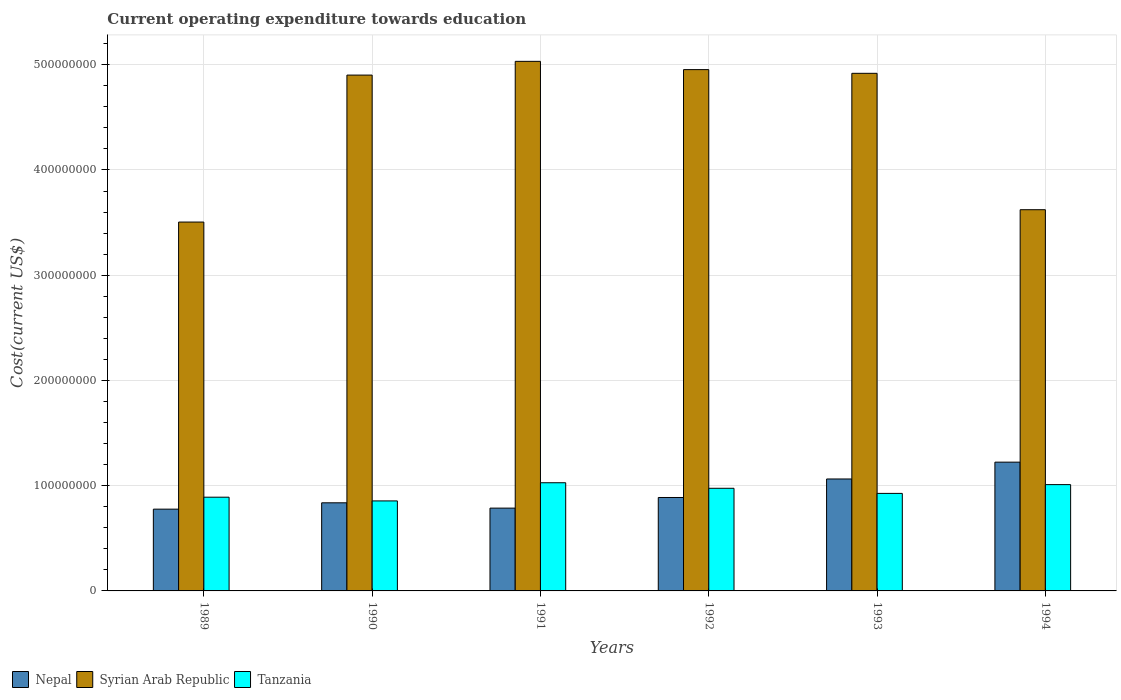How many different coloured bars are there?
Your answer should be very brief. 3. How many groups of bars are there?
Give a very brief answer. 6. Are the number of bars on each tick of the X-axis equal?
Offer a terse response. Yes. How many bars are there on the 3rd tick from the left?
Give a very brief answer. 3. What is the expenditure towards education in Tanzania in 1994?
Your response must be concise. 1.01e+08. Across all years, what is the maximum expenditure towards education in Tanzania?
Make the answer very short. 1.03e+08. Across all years, what is the minimum expenditure towards education in Syrian Arab Republic?
Offer a very short reply. 3.50e+08. In which year was the expenditure towards education in Syrian Arab Republic minimum?
Provide a succinct answer. 1989. What is the total expenditure towards education in Nepal in the graph?
Offer a very short reply. 5.58e+08. What is the difference between the expenditure towards education in Syrian Arab Republic in 1992 and that in 1993?
Your answer should be very brief. 3.51e+06. What is the difference between the expenditure towards education in Syrian Arab Republic in 1991 and the expenditure towards education in Nepal in 1990?
Give a very brief answer. 4.19e+08. What is the average expenditure towards education in Tanzania per year?
Your answer should be very brief. 9.48e+07. In the year 1993, what is the difference between the expenditure towards education in Syrian Arab Republic and expenditure towards education in Tanzania?
Give a very brief answer. 3.99e+08. In how many years, is the expenditure towards education in Tanzania greater than 320000000 US$?
Keep it short and to the point. 0. What is the ratio of the expenditure towards education in Tanzania in 1989 to that in 1990?
Ensure brevity in your answer.  1.04. Is the expenditure towards education in Tanzania in 1991 less than that in 1994?
Offer a terse response. No. Is the difference between the expenditure towards education in Syrian Arab Republic in 1990 and 1991 greater than the difference between the expenditure towards education in Tanzania in 1990 and 1991?
Give a very brief answer. Yes. What is the difference between the highest and the second highest expenditure towards education in Tanzania?
Your answer should be very brief. 1.79e+06. What is the difference between the highest and the lowest expenditure towards education in Nepal?
Offer a terse response. 4.47e+07. In how many years, is the expenditure towards education in Syrian Arab Republic greater than the average expenditure towards education in Syrian Arab Republic taken over all years?
Provide a short and direct response. 4. Is the sum of the expenditure towards education in Nepal in 1990 and 1991 greater than the maximum expenditure towards education in Syrian Arab Republic across all years?
Provide a short and direct response. No. What does the 1st bar from the left in 1994 represents?
Provide a succinct answer. Nepal. What does the 2nd bar from the right in 1992 represents?
Offer a terse response. Syrian Arab Republic. Are all the bars in the graph horizontal?
Your answer should be very brief. No. How many years are there in the graph?
Your answer should be very brief. 6. What is the difference between two consecutive major ticks on the Y-axis?
Keep it short and to the point. 1.00e+08. What is the title of the graph?
Your answer should be very brief. Current operating expenditure towards education. What is the label or title of the Y-axis?
Offer a terse response. Cost(current US$). What is the Cost(current US$) of Nepal in 1989?
Provide a short and direct response. 7.77e+07. What is the Cost(current US$) in Syrian Arab Republic in 1989?
Offer a terse response. 3.50e+08. What is the Cost(current US$) in Tanzania in 1989?
Your answer should be compact. 8.91e+07. What is the Cost(current US$) in Nepal in 1990?
Offer a very short reply. 8.37e+07. What is the Cost(current US$) of Syrian Arab Republic in 1990?
Ensure brevity in your answer.  4.90e+08. What is the Cost(current US$) of Tanzania in 1990?
Your answer should be compact. 8.55e+07. What is the Cost(current US$) of Nepal in 1991?
Keep it short and to the point. 7.87e+07. What is the Cost(current US$) of Syrian Arab Republic in 1991?
Provide a short and direct response. 5.03e+08. What is the Cost(current US$) in Tanzania in 1991?
Your answer should be compact. 1.03e+08. What is the Cost(current US$) in Nepal in 1992?
Give a very brief answer. 8.88e+07. What is the Cost(current US$) in Syrian Arab Republic in 1992?
Give a very brief answer. 4.95e+08. What is the Cost(current US$) of Tanzania in 1992?
Ensure brevity in your answer.  9.75e+07. What is the Cost(current US$) of Nepal in 1993?
Keep it short and to the point. 1.06e+08. What is the Cost(current US$) of Syrian Arab Republic in 1993?
Provide a short and direct response. 4.92e+08. What is the Cost(current US$) of Tanzania in 1993?
Give a very brief answer. 9.27e+07. What is the Cost(current US$) in Nepal in 1994?
Your response must be concise. 1.22e+08. What is the Cost(current US$) of Syrian Arab Republic in 1994?
Offer a terse response. 3.62e+08. What is the Cost(current US$) in Tanzania in 1994?
Offer a terse response. 1.01e+08. Across all years, what is the maximum Cost(current US$) of Nepal?
Give a very brief answer. 1.22e+08. Across all years, what is the maximum Cost(current US$) of Syrian Arab Republic?
Offer a terse response. 5.03e+08. Across all years, what is the maximum Cost(current US$) of Tanzania?
Provide a succinct answer. 1.03e+08. Across all years, what is the minimum Cost(current US$) in Nepal?
Offer a very short reply. 7.77e+07. Across all years, what is the minimum Cost(current US$) of Syrian Arab Republic?
Give a very brief answer. 3.50e+08. Across all years, what is the minimum Cost(current US$) in Tanzania?
Ensure brevity in your answer.  8.55e+07. What is the total Cost(current US$) in Nepal in the graph?
Your response must be concise. 5.58e+08. What is the total Cost(current US$) in Syrian Arab Republic in the graph?
Offer a terse response. 2.69e+09. What is the total Cost(current US$) in Tanzania in the graph?
Ensure brevity in your answer.  5.69e+08. What is the difference between the Cost(current US$) in Nepal in 1989 and that in 1990?
Offer a terse response. -6.02e+06. What is the difference between the Cost(current US$) of Syrian Arab Republic in 1989 and that in 1990?
Keep it short and to the point. -1.40e+08. What is the difference between the Cost(current US$) of Tanzania in 1989 and that in 1990?
Ensure brevity in your answer.  3.54e+06. What is the difference between the Cost(current US$) of Nepal in 1989 and that in 1991?
Give a very brief answer. -9.81e+05. What is the difference between the Cost(current US$) in Syrian Arab Republic in 1989 and that in 1991?
Your answer should be compact. -1.53e+08. What is the difference between the Cost(current US$) in Tanzania in 1989 and that in 1991?
Your response must be concise. -1.37e+07. What is the difference between the Cost(current US$) in Nepal in 1989 and that in 1992?
Provide a succinct answer. -1.11e+07. What is the difference between the Cost(current US$) of Syrian Arab Republic in 1989 and that in 1992?
Your response must be concise. -1.45e+08. What is the difference between the Cost(current US$) of Tanzania in 1989 and that in 1992?
Provide a short and direct response. -8.45e+06. What is the difference between the Cost(current US$) in Nepal in 1989 and that in 1993?
Ensure brevity in your answer.  -2.87e+07. What is the difference between the Cost(current US$) in Syrian Arab Republic in 1989 and that in 1993?
Give a very brief answer. -1.41e+08. What is the difference between the Cost(current US$) in Tanzania in 1989 and that in 1993?
Offer a terse response. -3.60e+06. What is the difference between the Cost(current US$) of Nepal in 1989 and that in 1994?
Ensure brevity in your answer.  -4.47e+07. What is the difference between the Cost(current US$) of Syrian Arab Republic in 1989 and that in 1994?
Your answer should be compact. -1.17e+07. What is the difference between the Cost(current US$) of Tanzania in 1989 and that in 1994?
Make the answer very short. -1.19e+07. What is the difference between the Cost(current US$) in Nepal in 1990 and that in 1991?
Ensure brevity in your answer.  5.04e+06. What is the difference between the Cost(current US$) in Syrian Arab Republic in 1990 and that in 1991?
Your response must be concise. -1.30e+07. What is the difference between the Cost(current US$) in Tanzania in 1990 and that in 1991?
Your answer should be very brief. -1.73e+07. What is the difference between the Cost(current US$) of Nepal in 1990 and that in 1992?
Keep it short and to the point. -5.05e+06. What is the difference between the Cost(current US$) of Syrian Arab Republic in 1990 and that in 1992?
Make the answer very short. -5.19e+06. What is the difference between the Cost(current US$) of Tanzania in 1990 and that in 1992?
Your answer should be very brief. -1.20e+07. What is the difference between the Cost(current US$) in Nepal in 1990 and that in 1993?
Keep it short and to the point. -2.26e+07. What is the difference between the Cost(current US$) of Syrian Arab Republic in 1990 and that in 1993?
Give a very brief answer. -1.68e+06. What is the difference between the Cost(current US$) in Tanzania in 1990 and that in 1993?
Offer a very short reply. -7.15e+06. What is the difference between the Cost(current US$) of Nepal in 1990 and that in 1994?
Ensure brevity in your answer.  -3.86e+07. What is the difference between the Cost(current US$) of Syrian Arab Republic in 1990 and that in 1994?
Keep it short and to the point. 1.28e+08. What is the difference between the Cost(current US$) of Tanzania in 1990 and that in 1994?
Provide a succinct answer. -1.55e+07. What is the difference between the Cost(current US$) of Nepal in 1991 and that in 1992?
Make the answer very short. -1.01e+07. What is the difference between the Cost(current US$) of Syrian Arab Republic in 1991 and that in 1992?
Make the answer very short. 7.86e+06. What is the difference between the Cost(current US$) in Tanzania in 1991 and that in 1992?
Your answer should be compact. 5.28e+06. What is the difference between the Cost(current US$) in Nepal in 1991 and that in 1993?
Provide a short and direct response. -2.77e+07. What is the difference between the Cost(current US$) in Syrian Arab Republic in 1991 and that in 1993?
Offer a terse response. 1.14e+07. What is the difference between the Cost(current US$) in Tanzania in 1991 and that in 1993?
Ensure brevity in your answer.  1.01e+07. What is the difference between the Cost(current US$) of Nepal in 1991 and that in 1994?
Ensure brevity in your answer.  -4.37e+07. What is the difference between the Cost(current US$) in Syrian Arab Republic in 1991 and that in 1994?
Provide a succinct answer. 1.41e+08. What is the difference between the Cost(current US$) in Tanzania in 1991 and that in 1994?
Keep it short and to the point. 1.79e+06. What is the difference between the Cost(current US$) of Nepal in 1992 and that in 1993?
Ensure brevity in your answer.  -1.76e+07. What is the difference between the Cost(current US$) in Syrian Arab Republic in 1992 and that in 1993?
Your answer should be compact. 3.51e+06. What is the difference between the Cost(current US$) in Tanzania in 1992 and that in 1993?
Ensure brevity in your answer.  4.85e+06. What is the difference between the Cost(current US$) in Nepal in 1992 and that in 1994?
Ensure brevity in your answer.  -3.36e+07. What is the difference between the Cost(current US$) in Syrian Arab Republic in 1992 and that in 1994?
Offer a terse response. 1.33e+08. What is the difference between the Cost(current US$) in Tanzania in 1992 and that in 1994?
Provide a succinct answer. -3.49e+06. What is the difference between the Cost(current US$) in Nepal in 1993 and that in 1994?
Provide a succinct answer. -1.60e+07. What is the difference between the Cost(current US$) of Syrian Arab Republic in 1993 and that in 1994?
Your answer should be compact. 1.30e+08. What is the difference between the Cost(current US$) of Tanzania in 1993 and that in 1994?
Your response must be concise. -8.34e+06. What is the difference between the Cost(current US$) of Nepal in 1989 and the Cost(current US$) of Syrian Arab Republic in 1990?
Keep it short and to the point. -4.12e+08. What is the difference between the Cost(current US$) in Nepal in 1989 and the Cost(current US$) in Tanzania in 1990?
Your answer should be compact. -7.82e+06. What is the difference between the Cost(current US$) of Syrian Arab Republic in 1989 and the Cost(current US$) of Tanzania in 1990?
Give a very brief answer. 2.65e+08. What is the difference between the Cost(current US$) in Nepal in 1989 and the Cost(current US$) in Syrian Arab Republic in 1991?
Keep it short and to the point. -4.25e+08. What is the difference between the Cost(current US$) in Nepal in 1989 and the Cost(current US$) in Tanzania in 1991?
Make the answer very short. -2.51e+07. What is the difference between the Cost(current US$) in Syrian Arab Republic in 1989 and the Cost(current US$) in Tanzania in 1991?
Offer a very short reply. 2.48e+08. What is the difference between the Cost(current US$) in Nepal in 1989 and the Cost(current US$) in Syrian Arab Republic in 1992?
Your response must be concise. -4.18e+08. What is the difference between the Cost(current US$) in Nepal in 1989 and the Cost(current US$) in Tanzania in 1992?
Your answer should be compact. -1.98e+07. What is the difference between the Cost(current US$) in Syrian Arab Republic in 1989 and the Cost(current US$) in Tanzania in 1992?
Keep it short and to the point. 2.53e+08. What is the difference between the Cost(current US$) of Nepal in 1989 and the Cost(current US$) of Syrian Arab Republic in 1993?
Your answer should be compact. -4.14e+08. What is the difference between the Cost(current US$) of Nepal in 1989 and the Cost(current US$) of Tanzania in 1993?
Keep it short and to the point. -1.50e+07. What is the difference between the Cost(current US$) in Syrian Arab Republic in 1989 and the Cost(current US$) in Tanzania in 1993?
Make the answer very short. 2.58e+08. What is the difference between the Cost(current US$) of Nepal in 1989 and the Cost(current US$) of Syrian Arab Republic in 1994?
Offer a very short reply. -2.85e+08. What is the difference between the Cost(current US$) of Nepal in 1989 and the Cost(current US$) of Tanzania in 1994?
Ensure brevity in your answer.  -2.33e+07. What is the difference between the Cost(current US$) of Syrian Arab Republic in 1989 and the Cost(current US$) of Tanzania in 1994?
Offer a very short reply. 2.49e+08. What is the difference between the Cost(current US$) in Nepal in 1990 and the Cost(current US$) in Syrian Arab Republic in 1991?
Keep it short and to the point. -4.19e+08. What is the difference between the Cost(current US$) in Nepal in 1990 and the Cost(current US$) in Tanzania in 1991?
Your answer should be compact. -1.91e+07. What is the difference between the Cost(current US$) of Syrian Arab Republic in 1990 and the Cost(current US$) of Tanzania in 1991?
Offer a very short reply. 3.87e+08. What is the difference between the Cost(current US$) in Nepal in 1990 and the Cost(current US$) in Syrian Arab Republic in 1992?
Provide a short and direct response. -4.12e+08. What is the difference between the Cost(current US$) of Nepal in 1990 and the Cost(current US$) of Tanzania in 1992?
Provide a succinct answer. -1.38e+07. What is the difference between the Cost(current US$) in Syrian Arab Republic in 1990 and the Cost(current US$) in Tanzania in 1992?
Offer a very short reply. 3.93e+08. What is the difference between the Cost(current US$) of Nepal in 1990 and the Cost(current US$) of Syrian Arab Republic in 1993?
Your answer should be compact. -4.08e+08. What is the difference between the Cost(current US$) in Nepal in 1990 and the Cost(current US$) in Tanzania in 1993?
Make the answer very short. -8.94e+06. What is the difference between the Cost(current US$) in Syrian Arab Republic in 1990 and the Cost(current US$) in Tanzania in 1993?
Give a very brief answer. 3.97e+08. What is the difference between the Cost(current US$) of Nepal in 1990 and the Cost(current US$) of Syrian Arab Republic in 1994?
Provide a succinct answer. -2.78e+08. What is the difference between the Cost(current US$) of Nepal in 1990 and the Cost(current US$) of Tanzania in 1994?
Give a very brief answer. -1.73e+07. What is the difference between the Cost(current US$) of Syrian Arab Republic in 1990 and the Cost(current US$) of Tanzania in 1994?
Offer a terse response. 3.89e+08. What is the difference between the Cost(current US$) in Nepal in 1991 and the Cost(current US$) in Syrian Arab Republic in 1992?
Your response must be concise. -4.17e+08. What is the difference between the Cost(current US$) in Nepal in 1991 and the Cost(current US$) in Tanzania in 1992?
Offer a terse response. -1.88e+07. What is the difference between the Cost(current US$) in Syrian Arab Republic in 1991 and the Cost(current US$) in Tanzania in 1992?
Your answer should be very brief. 4.06e+08. What is the difference between the Cost(current US$) of Nepal in 1991 and the Cost(current US$) of Syrian Arab Republic in 1993?
Keep it short and to the point. -4.13e+08. What is the difference between the Cost(current US$) of Nepal in 1991 and the Cost(current US$) of Tanzania in 1993?
Your answer should be very brief. -1.40e+07. What is the difference between the Cost(current US$) in Syrian Arab Republic in 1991 and the Cost(current US$) in Tanzania in 1993?
Your answer should be compact. 4.11e+08. What is the difference between the Cost(current US$) of Nepal in 1991 and the Cost(current US$) of Syrian Arab Republic in 1994?
Offer a very short reply. -2.84e+08. What is the difference between the Cost(current US$) of Nepal in 1991 and the Cost(current US$) of Tanzania in 1994?
Offer a terse response. -2.23e+07. What is the difference between the Cost(current US$) of Syrian Arab Republic in 1991 and the Cost(current US$) of Tanzania in 1994?
Provide a succinct answer. 4.02e+08. What is the difference between the Cost(current US$) in Nepal in 1992 and the Cost(current US$) in Syrian Arab Republic in 1993?
Keep it short and to the point. -4.03e+08. What is the difference between the Cost(current US$) in Nepal in 1992 and the Cost(current US$) in Tanzania in 1993?
Your answer should be very brief. -3.89e+06. What is the difference between the Cost(current US$) in Syrian Arab Republic in 1992 and the Cost(current US$) in Tanzania in 1993?
Your response must be concise. 4.03e+08. What is the difference between the Cost(current US$) in Nepal in 1992 and the Cost(current US$) in Syrian Arab Republic in 1994?
Ensure brevity in your answer.  -2.73e+08. What is the difference between the Cost(current US$) of Nepal in 1992 and the Cost(current US$) of Tanzania in 1994?
Your answer should be very brief. -1.22e+07. What is the difference between the Cost(current US$) of Syrian Arab Republic in 1992 and the Cost(current US$) of Tanzania in 1994?
Keep it short and to the point. 3.94e+08. What is the difference between the Cost(current US$) of Nepal in 1993 and the Cost(current US$) of Syrian Arab Republic in 1994?
Your answer should be compact. -2.56e+08. What is the difference between the Cost(current US$) of Nepal in 1993 and the Cost(current US$) of Tanzania in 1994?
Your response must be concise. 5.36e+06. What is the difference between the Cost(current US$) of Syrian Arab Republic in 1993 and the Cost(current US$) of Tanzania in 1994?
Provide a succinct answer. 3.91e+08. What is the average Cost(current US$) of Nepal per year?
Your response must be concise. 9.29e+07. What is the average Cost(current US$) of Syrian Arab Republic per year?
Provide a succinct answer. 4.49e+08. What is the average Cost(current US$) in Tanzania per year?
Offer a very short reply. 9.48e+07. In the year 1989, what is the difference between the Cost(current US$) in Nepal and Cost(current US$) in Syrian Arab Republic?
Provide a succinct answer. -2.73e+08. In the year 1989, what is the difference between the Cost(current US$) of Nepal and Cost(current US$) of Tanzania?
Keep it short and to the point. -1.14e+07. In the year 1989, what is the difference between the Cost(current US$) of Syrian Arab Republic and Cost(current US$) of Tanzania?
Make the answer very short. 2.61e+08. In the year 1990, what is the difference between the Cost(current US$) of Nepal and Cost(current US$) of Syrian Arab Republic?
Make the answer very short. -4.06e+08. In the year 1990, what is the difference between the Cost(current US$) of Nepal and Cost(current US$) of Tanzania?
Provide a short and direct response. -1.79e+06. In the year 1990, what is the difference between the Cost(current US$) in Syrian Arab Republic and Cost(current US$) in Tanzania?
Provide a succinct answer. 4.05e+08. In the year 1991, what is the difference between the Cost(current US$) in Nepal and Cost(current US$) in Syrian Arab Republic?
Offer a terse response. -4.25e+08. In the year 1991, what is the difference between the Cost(current US$) of Nepal and Cost(current US$) of Tanzania?
Provide a succinct answer. -2.41e+07. In the year 1991, what is the difference between the Cost(current US$) of Syrian Arab Republic and Cost(current US$) of Tanzania?
Provide a short and direct response. 4.00e+08. In the year 1992, what is the difference between the Cost(current US$) of Nepal and Cost(current US$) of Syrian Arab Republic?
Give a very brief answer. -4.07e+08. In the year 1992, what is the difference between the Cost(current US$) in Nepal and Cost(current US$) in Tanzania?
Give a very brief answer. -8.74e+06. In the year 1992, what is the difference between the Cost(current US$) of Syrian Arab Republic and Cost(current US$) of Tanzania?
Make the answer very short. 3.98e+08. In the year 1993, what is the difference between the Cost(current US$) of Nepal and Cost(current US$) of Syrian Arab Republic?
Provide a succinct answer. -3.85e+08. In the year 1993, what is the difference between the Cost(current US$) of Nepal and Cost(current US$) of Tanzania?
Your answer should be very brief. 1.37e+07. In the year 1993, what is the difference between the Cost(current US$) in Syrian Arab Republic and Cost(current US$) in Tanzania?
Make the answer very short. 3.99e+08. In the year 1994, what is the difference between the Cost(current US$) of Nepal and Cost(current US$) of Syrian Arab Republic?
Make the answer very short. -2.40e+08. In the year 1994, what is the difference between the Cost(current US$) in Nepal and Cost(current US$) in Tanzania?
Ensure brevity in your answer.  2.14e+07. In the year 1994, what is the difference between the Cost(current US$) of Syrian Arab Republic and Cost(current US$) of Tanzania?
Offer a terse response. 2.61e+08. What is the ratio of the Cost(current US$) of Nepal in 1989 to that in 1990?
Provide a succinct answer. 0.93. What is the ratio of the Cost(current US$) of Syrian Arab Republic in 1989 to that in 1990?
Keep it short and to the point. 0.72. What is the ratio of the Cost(current US$) of Tanzania in 1989 to that in 1990?
Provide a short and direct response. 1.04. What is the ratio of the Cost(current US$) of Nepal in 1989 to that in 1991?
Your response must be concise. 0.99. What is the ratio of the Cost(current US$) in Syrian Arab Republic in 1989 to that in 1991?
Provide a short and direct response. 0.7. What is the ratio of the Cost(current US$) in Tanzania in 1989 to that in 1991?
Ensure brevity in your answer.  0.87. What is the ratio of the Cost(current US$) of Nepal in 1989 to that in 1992?
Your answer should be compact. 0.88. What is the ratio of the Cost(current US$) of Syrian Arab Republic in 1989 to that in 1992?
Ensure brevity in your answer.  0.71. What is the ratio of the Cost(current US$) of Tanzania in 1989 to that in 1992?
Your answer should be compact. 0.91. What is the ratio of the Cost(current US$) of Nepal in 1989 to that in 1993?
Your response must be concise. 0.73. What is the ratio of the Cost(current US$) in Syrian Arab Republic in 1989 to that in 1993?
Make the answer very short. 0.71. What is the ratio of the Cost(current US$) in Tanzania in 1989 to that in 1993?
Your response must be concise. 0.96. What is the ratio of the Cost(current US$) of Nepal in 1989 to that in 1994?
Give a very brief answer. 0.64. What is the ratio of the Cost(current US$) of Syrian Arab Republic in 1989 to that in 1994?
Provide a short and direct response. 0.97. What is the ratio of the Cost(current US$) in Tanzania in 1989 to that in 1994?
Keep it short and to the point. 0.88. What is the ratio of the Cost(current US$) of Nepal in 1990 to that in 1991?
Ensure brevity in your answer.  1.06. What is the ratio of the Cost(current US$) of Syrian Arab Republic in 1990 to that in 1991?
Your answer should be very brief. 0.97. What is the ratio of the Cost(current US$) of Tanzania in 1990 to that in 1991?
Keep it short and to the point. 0.83. What is the ratio of the Cost(current US$) of Nepal in 1990 to that in 1992?
Give a very brief answer. 0.94. What is the ratio of the Cost(current US$) of Tanzania in 1990 to that in 1992?
Offer a very short reply. 0.88. What is the ratio of the Cost(current US$) of Nepal in 1990 to that in 1993?
Ensure brevity in your answer.  0.79. What is the ratio of the Cost(current US$) of Tanzania in 1990 to that in 1993?
Offer a terse response. 0.92. What is the ratio of the Cost(current US$) in Nepal in 1990 to that in 1994?
Keep it short and to the point. 0.68. What is the ratio of the Cost(current US$) of Syrian Arab Republic in 1990 to that in 1994?
Your answer should be compact. 1.35. What is the ratio of the Cost(current US$) in Tanzania in 1990 to that in 1994?
Make the answer very short. 0.85. What is the ratio of the Cost(current US$) in Nepal in 1991 to that in 1992?
Ensure brevity in your answer.  0.89. What is the ratio of the Cost(current US$) of Syrian Arab Republic in 1991 to that in 1992?
Your answer should be compact. 1.02. What is the ratio of the Cost(current US$) in Tanzania in 1991 to that in 1992?
Offer a terse response. 1.05. What is the ratio of the Cost(current US$) in Nepal in 1991 to that in 1993?
Your answer should be compact. 0.74. What is the ratio of the Cost(current US$) of Syrian Arab Republic in 1991 to that in 1993?
Keep it short and to the point. 1.02. What is the ratio of the Cost(current US$) of Tanzania in 1991 to that in 1993?
Make the answer very short. 1.11. What is the ratio of the Cost(current US$) in Nepal in 1991 to that in 1994?
Your answer should be compact. 0.64. What is the ratio of the Cost(current US$) of Syrian Arab Republic in 1991 to that in 1994?
Your answer should be compact. 1.39. What is the ratio of the Cost(current US$) in Tanzania in 1991 to that in 1994?
Provide a succinct answer. 1.02. What is the ratio of the Cost(current US$) in Nepal in 1992 to that in 1993?
Make the answer very short. 0.83. What is the ratio of the Cost(current US$) in Syrian Arab Republic in 1992 to that in 1993?
Offer a very short reply. 1.01. What is the ratio of the Cost(current US$) of Tanzania in 1992 to that in 1993?
Make the answer very short. 1.05. What is the ratio of the Cost(current US$) in Nepal in 1992 to that in 1994?
Keep it short and to the point. 0.73. What is the ratio of the Cost(current US$) of Syrian Arab Republic in 1992 to that in 1994?
Your answer should be very brief. 1.37. What is the ratio of the Cost(current US$) in Tanzania in 1992 to that in 1994?
Make the answer very short. 0.97. What is the ratio of the Cost(current US$) of Nepal in 1993 to that in 1994?
Provide a short and direct response. 0.87. What is the ratio of the Cost(current US$) in Syrian Arab Republic in 1993 to that in 1994?
Ensure brevity in your answer.  1.36. What is the ratio of the Cost(current US$) of Tanzania in 1993 to that in 1994?
Make the answer very short. 0.92. What is the difference between the highest and the second highest Cost(current US$) of Nepal?
Keep it short and to the point. 1.60e+07. What is the difference between the highest and the second highest Cost(current US$) of Syrian Arab Republic?
Give a very brief answer. 7.86e+06. What is the difference between the highest and the second highest Cost(current US$) of Tanzania?
Give a very brief answer. 1.79e+06. What is the difference between the highest and the lowest Cost(current US$) in Nepal?
Make the answer very short. 4.47e+07. What is the difference between the highest and the lowest Cost(current US$) in Syrian Arab Republic?
Your answer should be compact. 1.53e+08. What is the difference between the highest and the lowest Cost(current US$) in Tanzania?
Ensure brevity in your answer.  1.73e+07. 